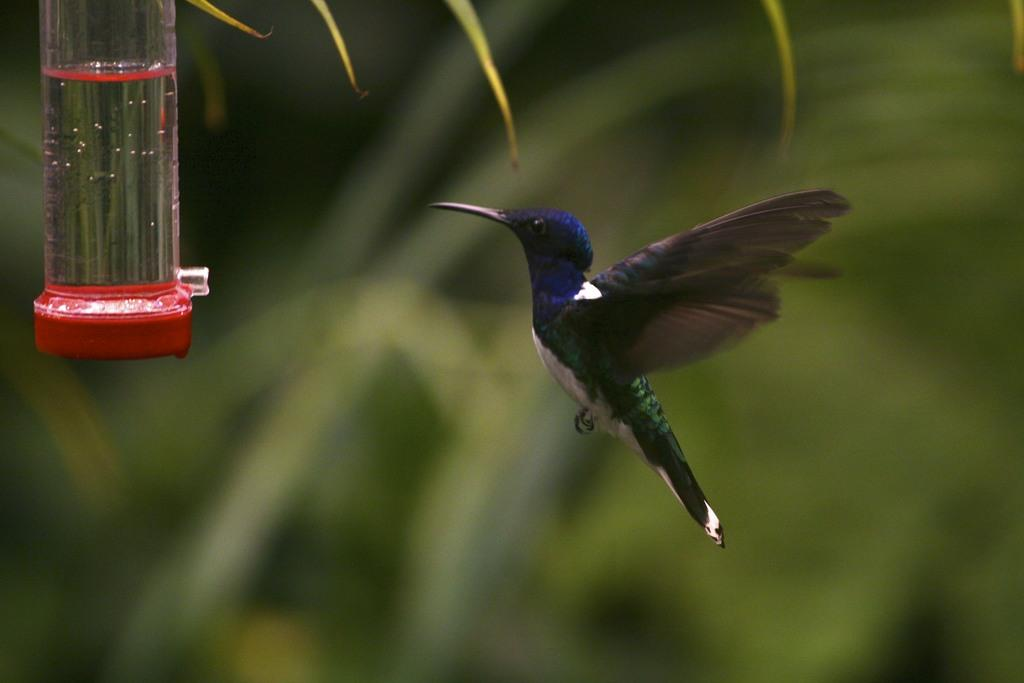What is the main subject of the image? There is a bird flying in the middle of the image. How would you describe the background of the image? The background of the image is blurred. Where is the bottle located in the image? The bottle is in the top left side of the image. What is inside the bottle? There is water inside the bottle. What type of steel is visible in the image? There is no steel present in the image. How does the sand move in the image? There is no sand present in the image. 